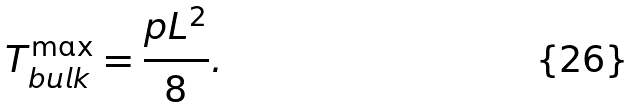Convert formula to latex. <formula><loc_0><loc_0><loc_500><loc_500>T _ { b u l k } ^ { \max } = \frac { p L ^ { 2 } } { 8 } .</formula> 